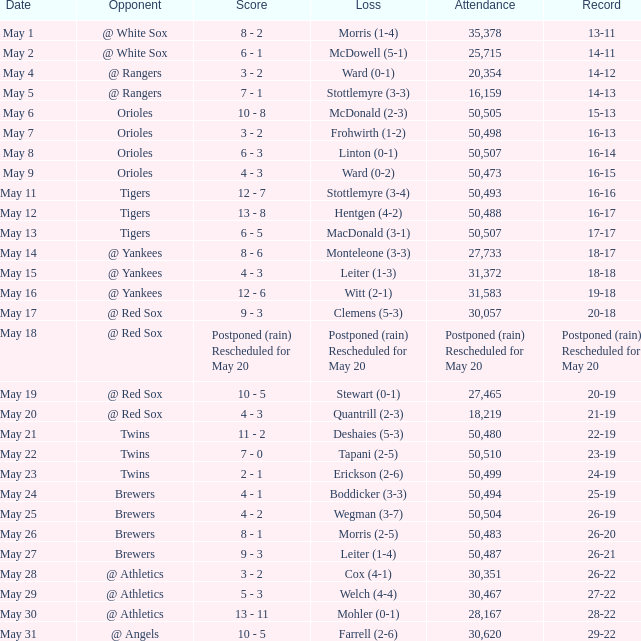On May 29 which team had the loss? Welch (4-4). 